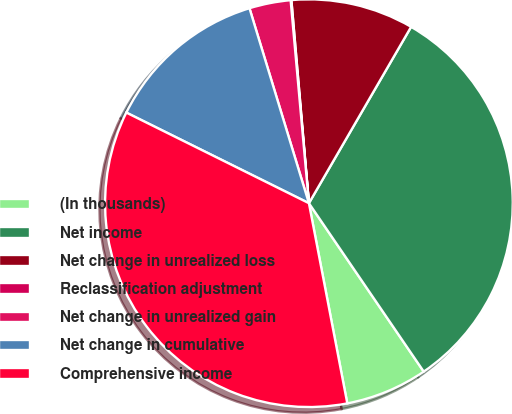Convert chart to OTSL. <chart><loc_0><loc_0><loc_500><loc_500><pie_chart><fcel>(In thousands)<fcel>Net income<fcel>Net change in unrealized loss<fcel>Reclassification adjustment<fcel>Net change in unrealized gain<fcel>Net change in cumulative<fcel>Comprehensive income<nl><fcel>6.51%<fcel>32.12%<fcel>9.73%<fcel>0.06%<fcel>3.28%<fcel>12.96%<fcel>35.35%<nl></chart> 